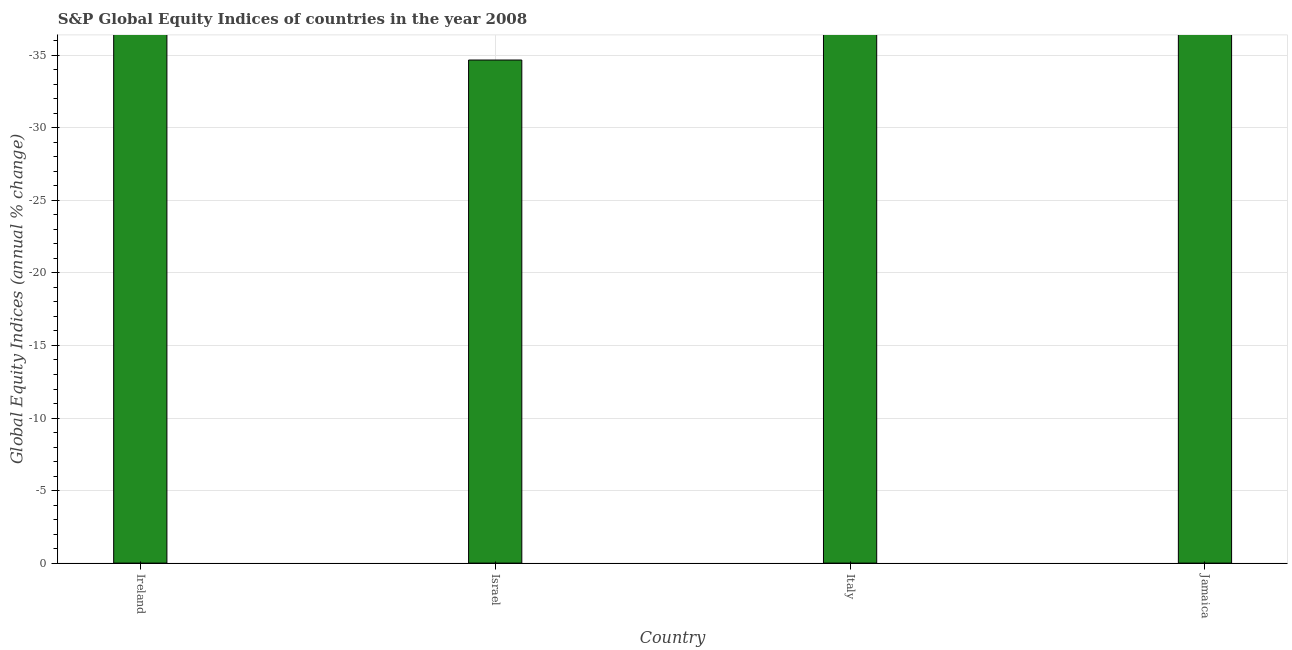Does the graph contain any zero values?
Make the answer very short. Yes. Does the graph contain grids?
Ensure brevity in your answer.  Yes. What is the title of the graph?
Your answer should be very brief. S&P Global Equity Indices of countries in the year 2008. What is the label or title of the X-axis?
Provide a succinct answer. Country. What is the label or title of the Y-axis?
Keep it short and to the point. Global Equity Indices (annual % change). What is the s&p global equity indices in Italy?
Keep it short and to the point. 0. What is the average s&p global equity indices per country?
Your answer should be very brief. 0. What is the median s&p global equity indices?
Your answer should be compact. 0. In how many countries, is the s&p global equity indices greater than the average s&p global equity indices taken over all countries?
Your answer should be very brief. 0. How many countries are there in the graph?
Provide a short and direct response. 4. What is the difference between two consecutive major ticks on the Y-axis?
Provide a short and direct response. 5. What is the Global Equity Indices (annual % change) in Ireland?
Keep it short and to the point. 0. What is the Global Equity Indices (annual % change) of Italy?
Make the answer very short. 0. 